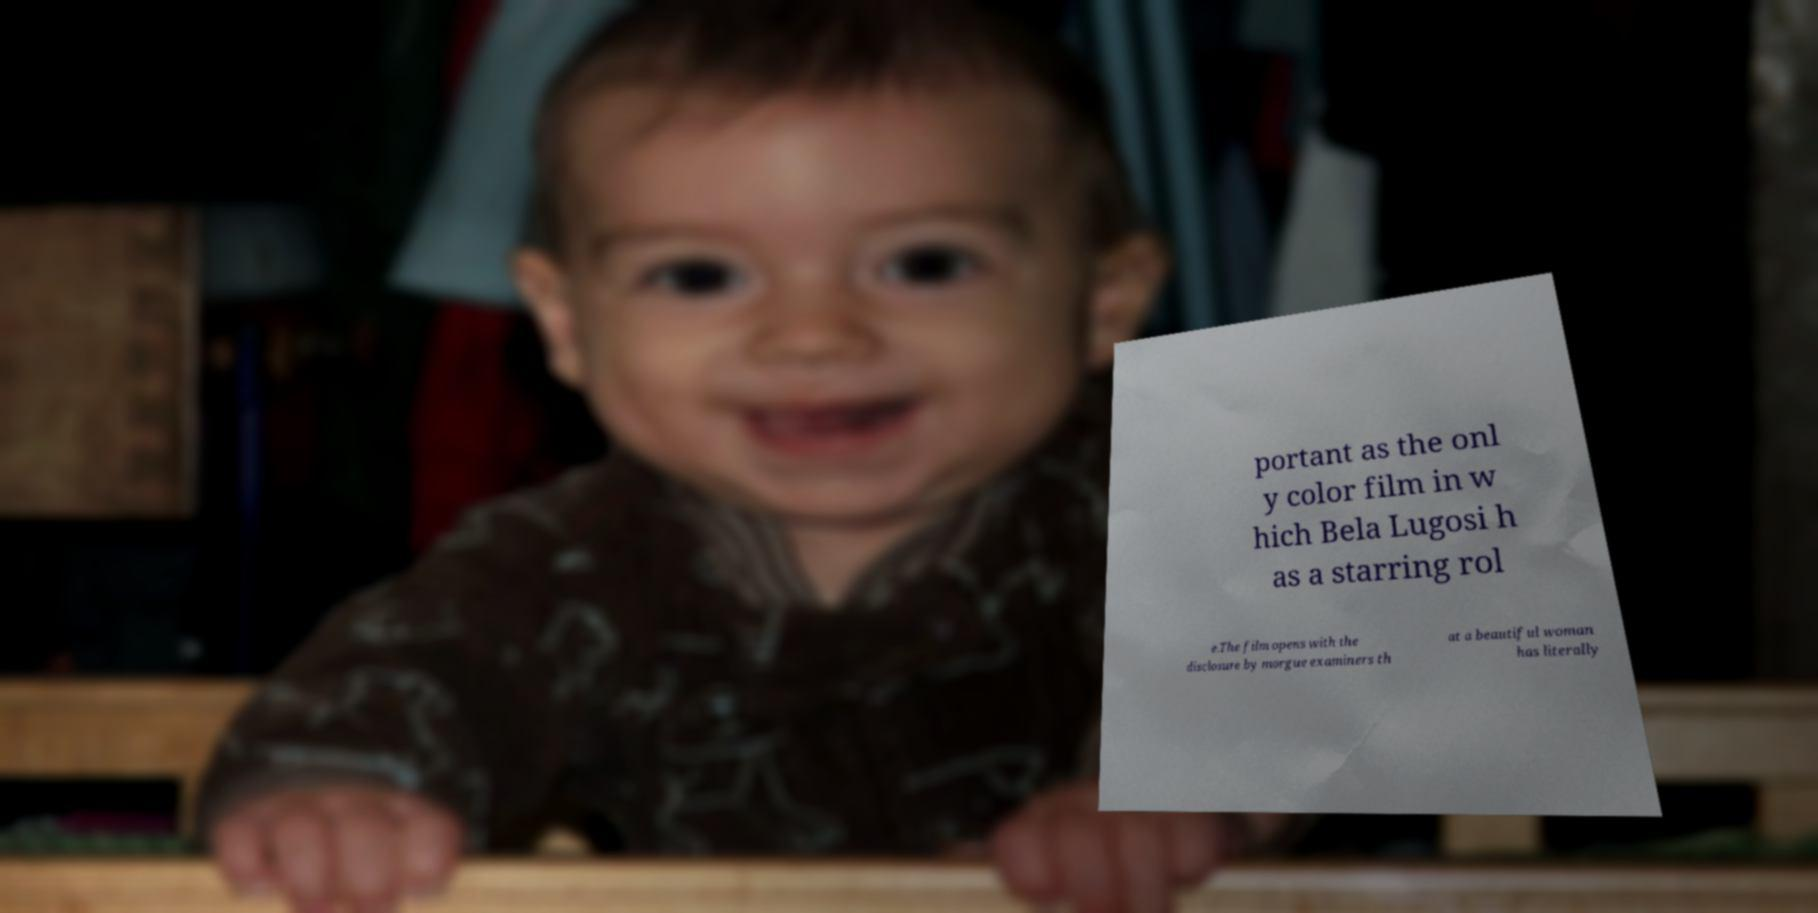For documentation purposes, I need the text within this image transcribed. Could you provide that? portant as the onl y color film in w hich Bela Lugosi h as a starring rol e.The film opens with the disclosure by morgue examiners th at a beautiful woman has literally 